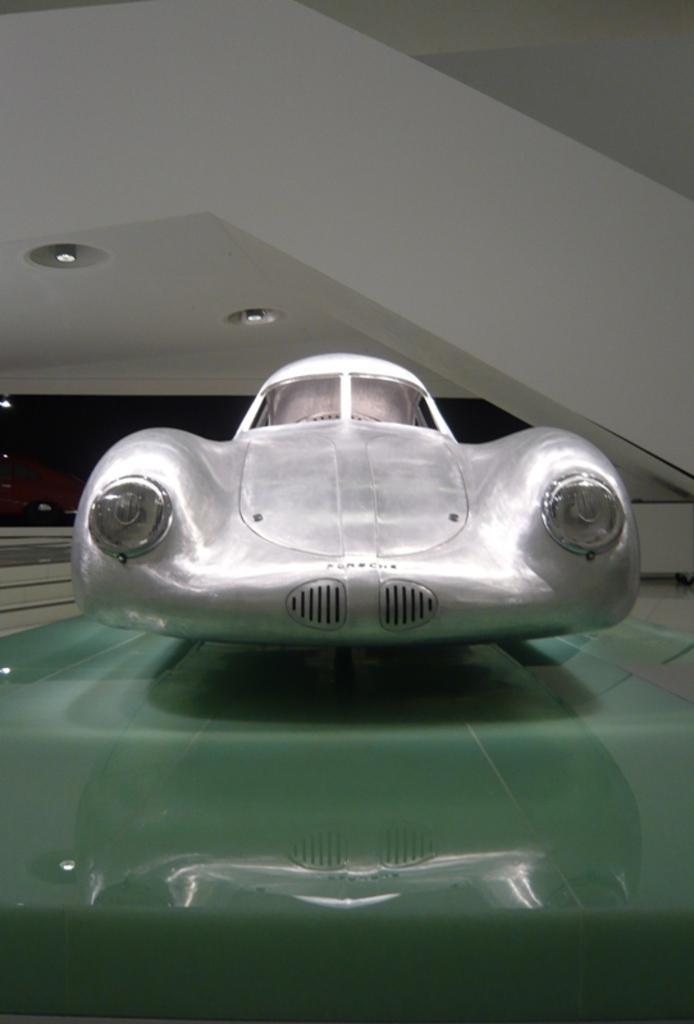Describe this image in one or two sentences. In this picture I can see a white color vehicle. In the background I can see lights on the ceiling. 